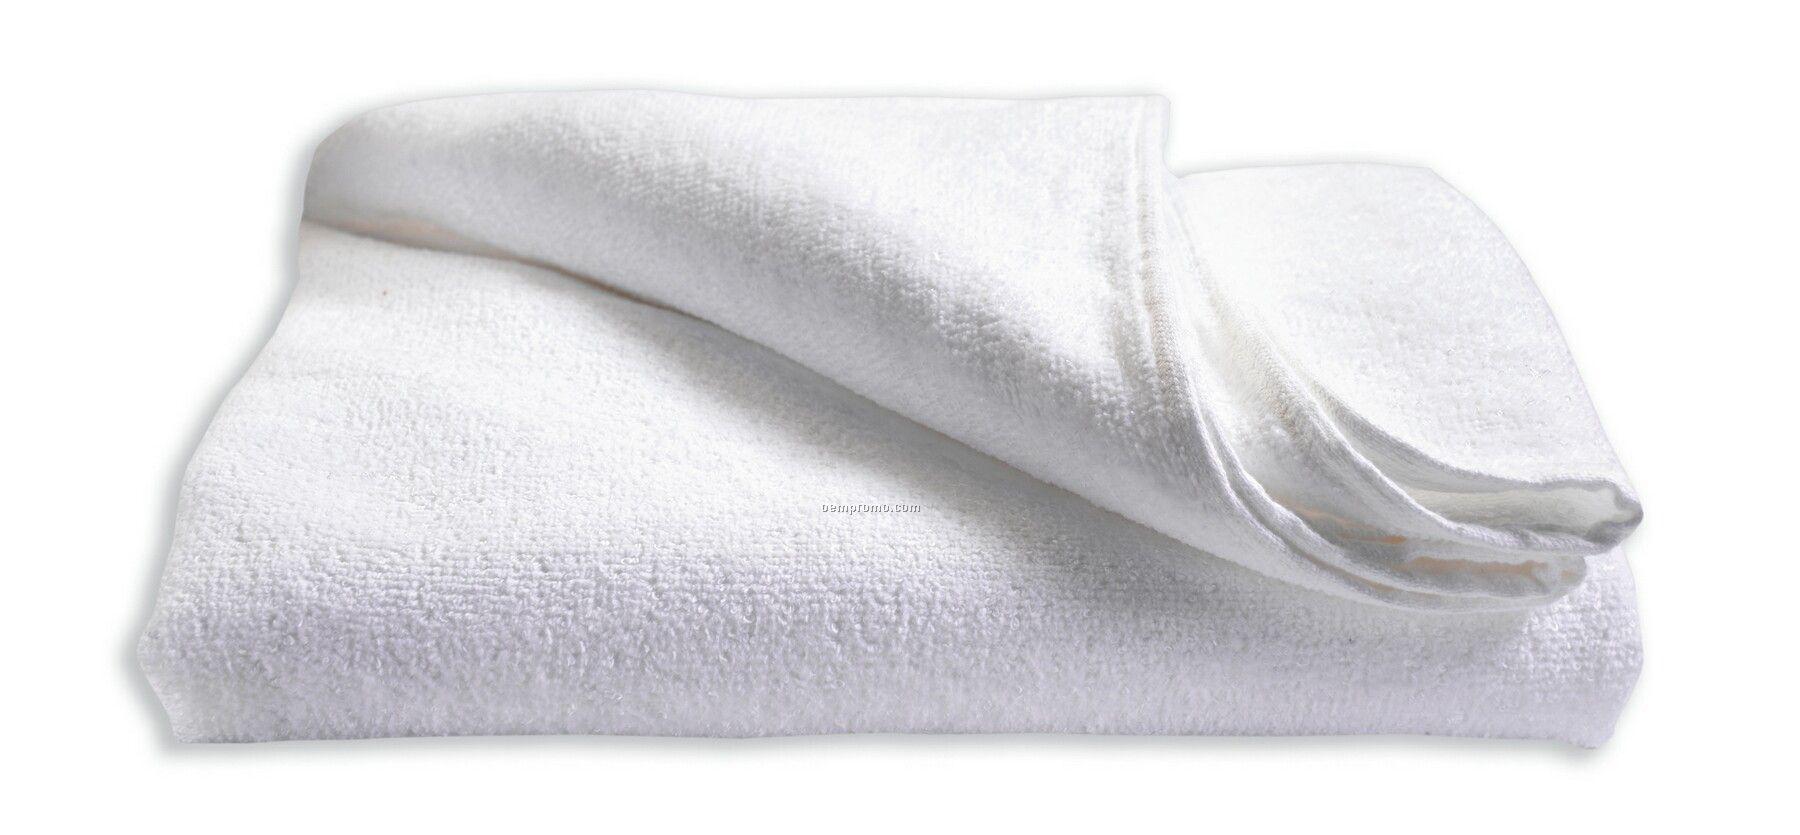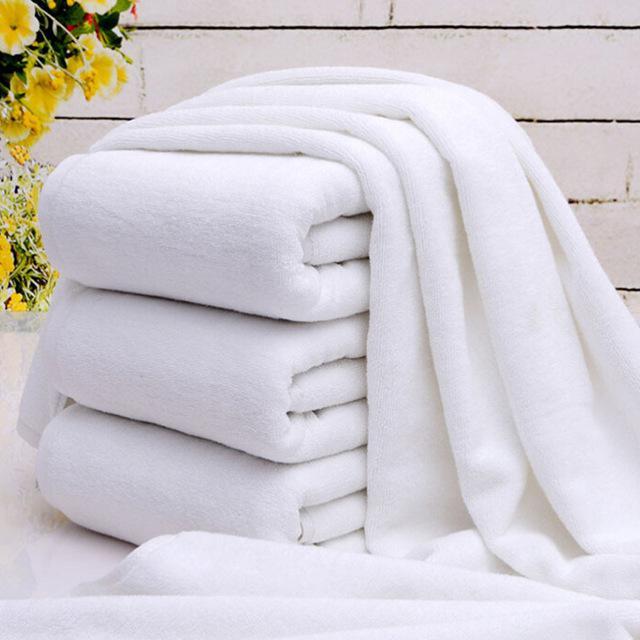The first image is the image on the left, the second image is the image on the right. Given the left and right images, does the statement "In one of the images, there are towels that are not folded or rolled." hold true? Answer yes or no. Yes. The first image is the image on the left, the second image is the image on the right. Assess this claim about the two images: "the right image has 4 neatly folded and stacked bath towels". Correct or not? Answer yes or no. No. 